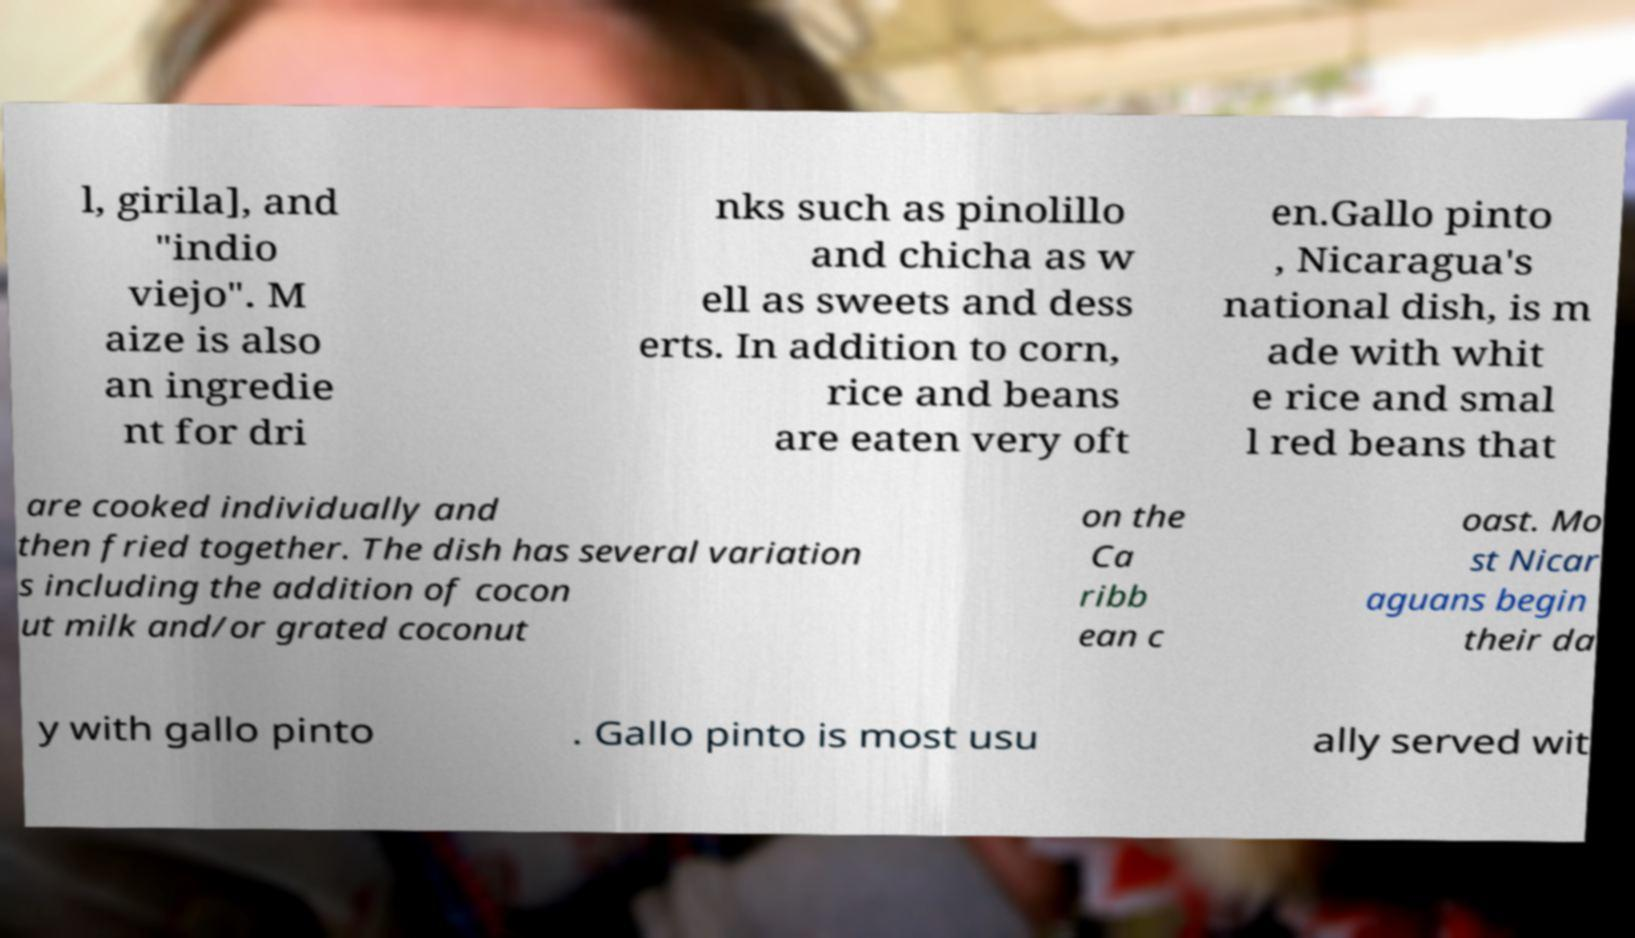Could you assist in decoding the text presented in this image and type it out clearly? l, girila], and "indio viejo". M aize is also an ingredie nt for dri nks such as pinolillo and chicha as w ell as sweets and dess erts. In addition to corn, rice and beans are eaten very oft en.Gallo pinto , Nicaragua's national dish, is m ade with whit e rice and smal l red beans that are cooked individually and then fried together. The dish has several variation s including the addition of cocon ut milk and/or grated coconut on the Ca ribb ean c oast. Mo st Nicar aguans begin their da y with gallo pinto . Gallo pinto is most usu ally served wit 